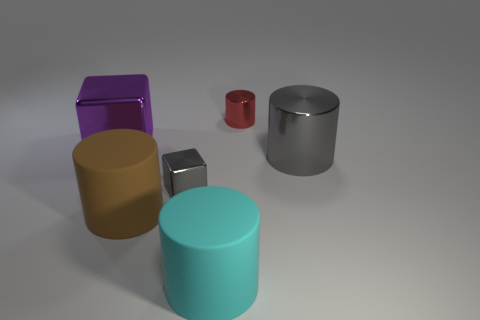Subtract all red cylinders. How many cylinders are left? 3 Subtract all gray cylinders. How many cylinders are left? 3 Subtract all cylinders. How many objects are left? 2 Subtract 2 cylinders. How many cylinders are left? 2 Subtract all small green cubes. Subtract all small red metal things. How many objects are left? 5 Add 1 large cyan matte objects. How many large cyan matte objects are left? 2 Add 4 gray shiny cylinders. How many gray shiny cylinders exist? 5 Add 3 big cylinders. How many objects exist? 9 Subtract 1 gray cylinders. How many objects are left? 5 Subtract all gray cylinders. Subtract all green blocks. How many cylinders are left? 3 